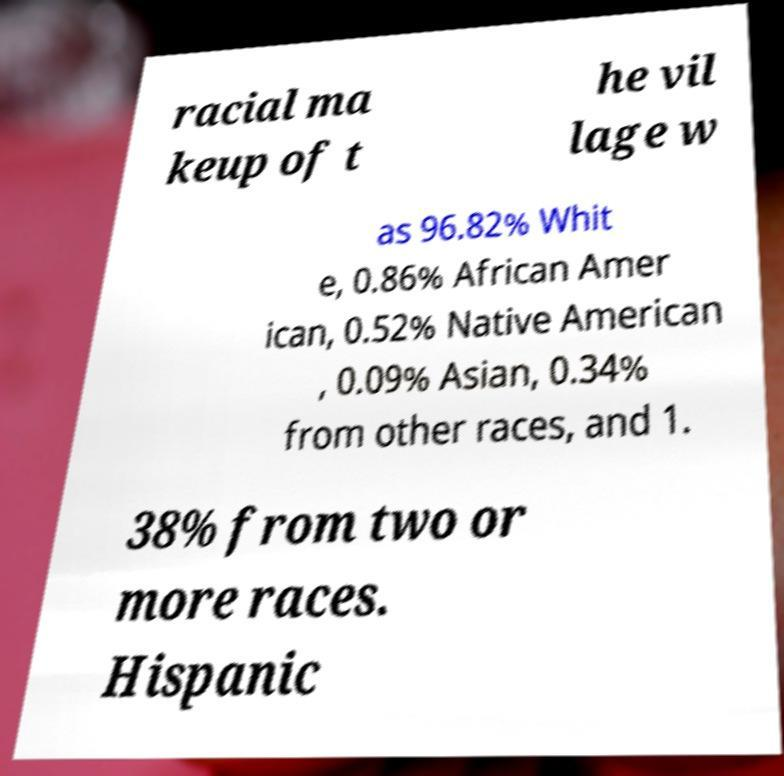What messages or text are displayed in this image? I need them in a readable, typed format. racial ma keup of t he vil lage w as 96.82% Whit e, 0.86% African Amer ican, 0.52% Native American , 0.09% Asian, 0.34% from other races, and 1. 38% from two or more races. Hispanic 